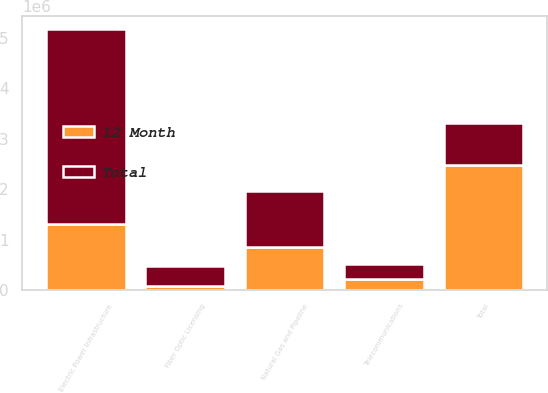Convert chart to OTSL. <chart><loc_0><loc_0><loc_500><loc_500><stacked_bar_chart><ecel><fcel>Electric Power Infrastructure<fcel>Natural Gas and Pipeline<fcel>Telecommunications<fcel>Fiber Optic Licensing<fcel>Total<nl><fcel>12 Month<fcel>1.31214e+06<fcel>847702<fcel>222999<fcel>87786<fcel>2.47063e+06<nl><fcel>Total<fcel>3.85532e+06<fcel>1.1208e+06<fcel>285295<fcel>387373<fcel>847702<nl></chart> 